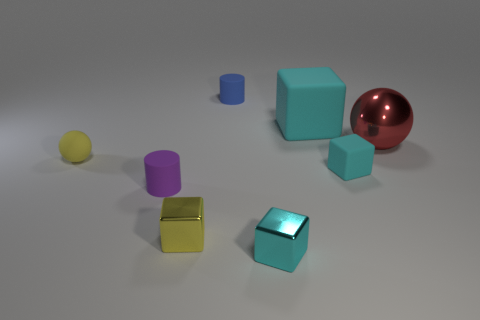There is a rubber thing that is the same color as the tiny rubber cube; what is its shape? The rubber object sharing the same color as the tiny cube has a spherical shape, similar to the larger red metallic sphere but significantly smaller in size. 